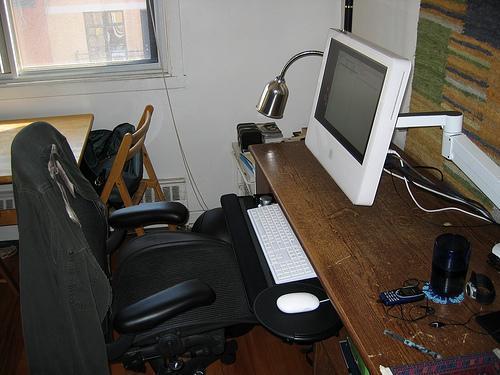How many chairs are there?
Give a very brief answer. 2. 